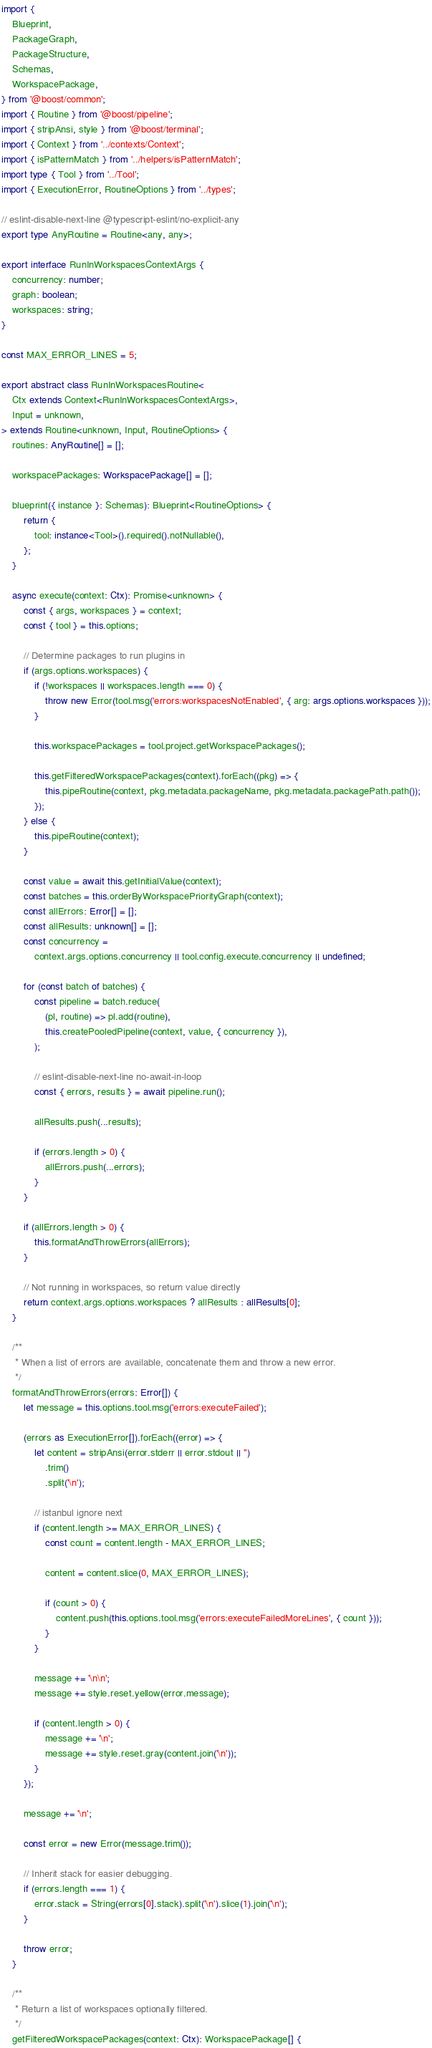<code> <loc_0><loc_0><loc_500><loc_500><_TypeScript_>import {
	Blueprint,
	PackageGraph,
	PackageStructure,
	Schemas,
	WorkspacePackage,
} from '@boost/common';
import { Routine } from '@boost/pipeline';
import { stripAnsi, style } from '@boost/terminal';
import { Context } from '../contexts/Context';
import { isPatternMatch } from '../helpers/isPatternMatch';
import type { Tool } from '../Tool';
import { ExecutionError, RoutineOptions } from '../types';

// eslint-disable-next-line @typescript-eslint/no-explicit-any
export type AnyRoutine = Routine<any, any>;

export interface RunInWorkspacesContextArgs {
	concurrency: number;
	graph: boolean;
	workspaces: string;
}

const MAX_ERROR_LINES = 5;

export abstract class RunInWorkspacesRoutine<
	Ctx extends Context<RunInWorkspacesContextArgs>,
	Input = unknown,
> extends Routine<unknown, Input, RoutineOptions> {
	routines: AnyRoutine[] = [];

	workspacePackages: WorkspacePackage[] = [];

	blueprint({ instance }: Schemas): Blueprint<RoutineOptions> {
		return {
			tool: instance<Tool>().required().notNullable(),
		};
	}

	async execute(context: Ctx): Promise<unknown> {
		const { args, workspaces } = context;
		const { tool } = this.options;

		// Determine packages to run plugins in
		if (args.options.workspaces) {
			if (!workspaces || workspaces.length === 0) {
				throw new Error(tool.msg('errors:workspacesNotEnabled', { arg: args.options.workspaces }));
			}

			this.workspacePackages = tool.project.getWorkspacePackages();

			this.getFilteredWorkspacePackages(context).forEach((pkg) => {
				this.pipeRoutine(context, pkg.metadata.packageName, pkg.metadata.packagePath.path());
			});
		} else {
			this.pipeRoutine(context);
		}

		const value = await this.getInitialValue(context);
		const batches = this.orderByWorkspacePriorityGraph(context);
		const allErrors: Error[] = [];
		const allResults: unknown[] = [];
		const concurrency =
			context.args.options.concurrency || tool.config.execute.concurrency || undefined;

		for (const batch of batches) {
			const pipeline = batch.reduce(
				(pl, routine) => pl.add(routine),
				this.createPooledPipeline(context, value, { concurrency }),
			);

			// eslint-disable-next-line no-await-in-loop
			const { errors, results } = await pipeline.run();

			allResults.push(...results);

			if (errors.length > 0) {
				allErrors.push(...errors);
			}
		}

		if (allErrors.length > 0) {
			this.formatAndThrowErrors(allErrors);
		}

		// Not running in workspaces, so return value directly
		return context.args.options.workspaces ? allResults : allResults[0];
	}

	/**
	 * When a list of errors are available, concatenate them and throw a new error.
	 */
	formatAndThrowErrors(errors: Error[]) {
		let message = this.options.tool.msg('errors:executeFailed');

		(errors as ExecutionError[]).forEach((error) => {
			let content = stripAnsi(error.stderr || error.stdout || '')
				.trim()
				.split('\n');

			// istanbul ignore next
			if (content.length >= MAX_ERROR_LINES) {
				const count = content.length - MAX_ERROR_LINES;

				content = content.slice(0, MAX_ERROR_LINES);

				if (count > 0) {
					content.push(this.options.tool.msg('errors:executeFailedMoreLines', { count }));
				}
			}

			message += '\n\n';
			message += style.reset.yellow(error.message);

			if (content.length > 0) {
				message += '\n';
				message += style.reset.gray(content.join('\n'));
			}
		});

		message += '\n';

		const error = new Error(message.trim());

		// Inherit stack for easier debugging.
		if (errors.length === 1) {
			error.stack = String(errors[0].stack).split('\n').slice(1).join('\n');
		}

		throw error;
	}

	/**
	 * Return a list of workspaces optionally filtered.
	 */
	getFilteredWorkspacePackages(context: Ctx): WorkspacePackage[] {</code> 